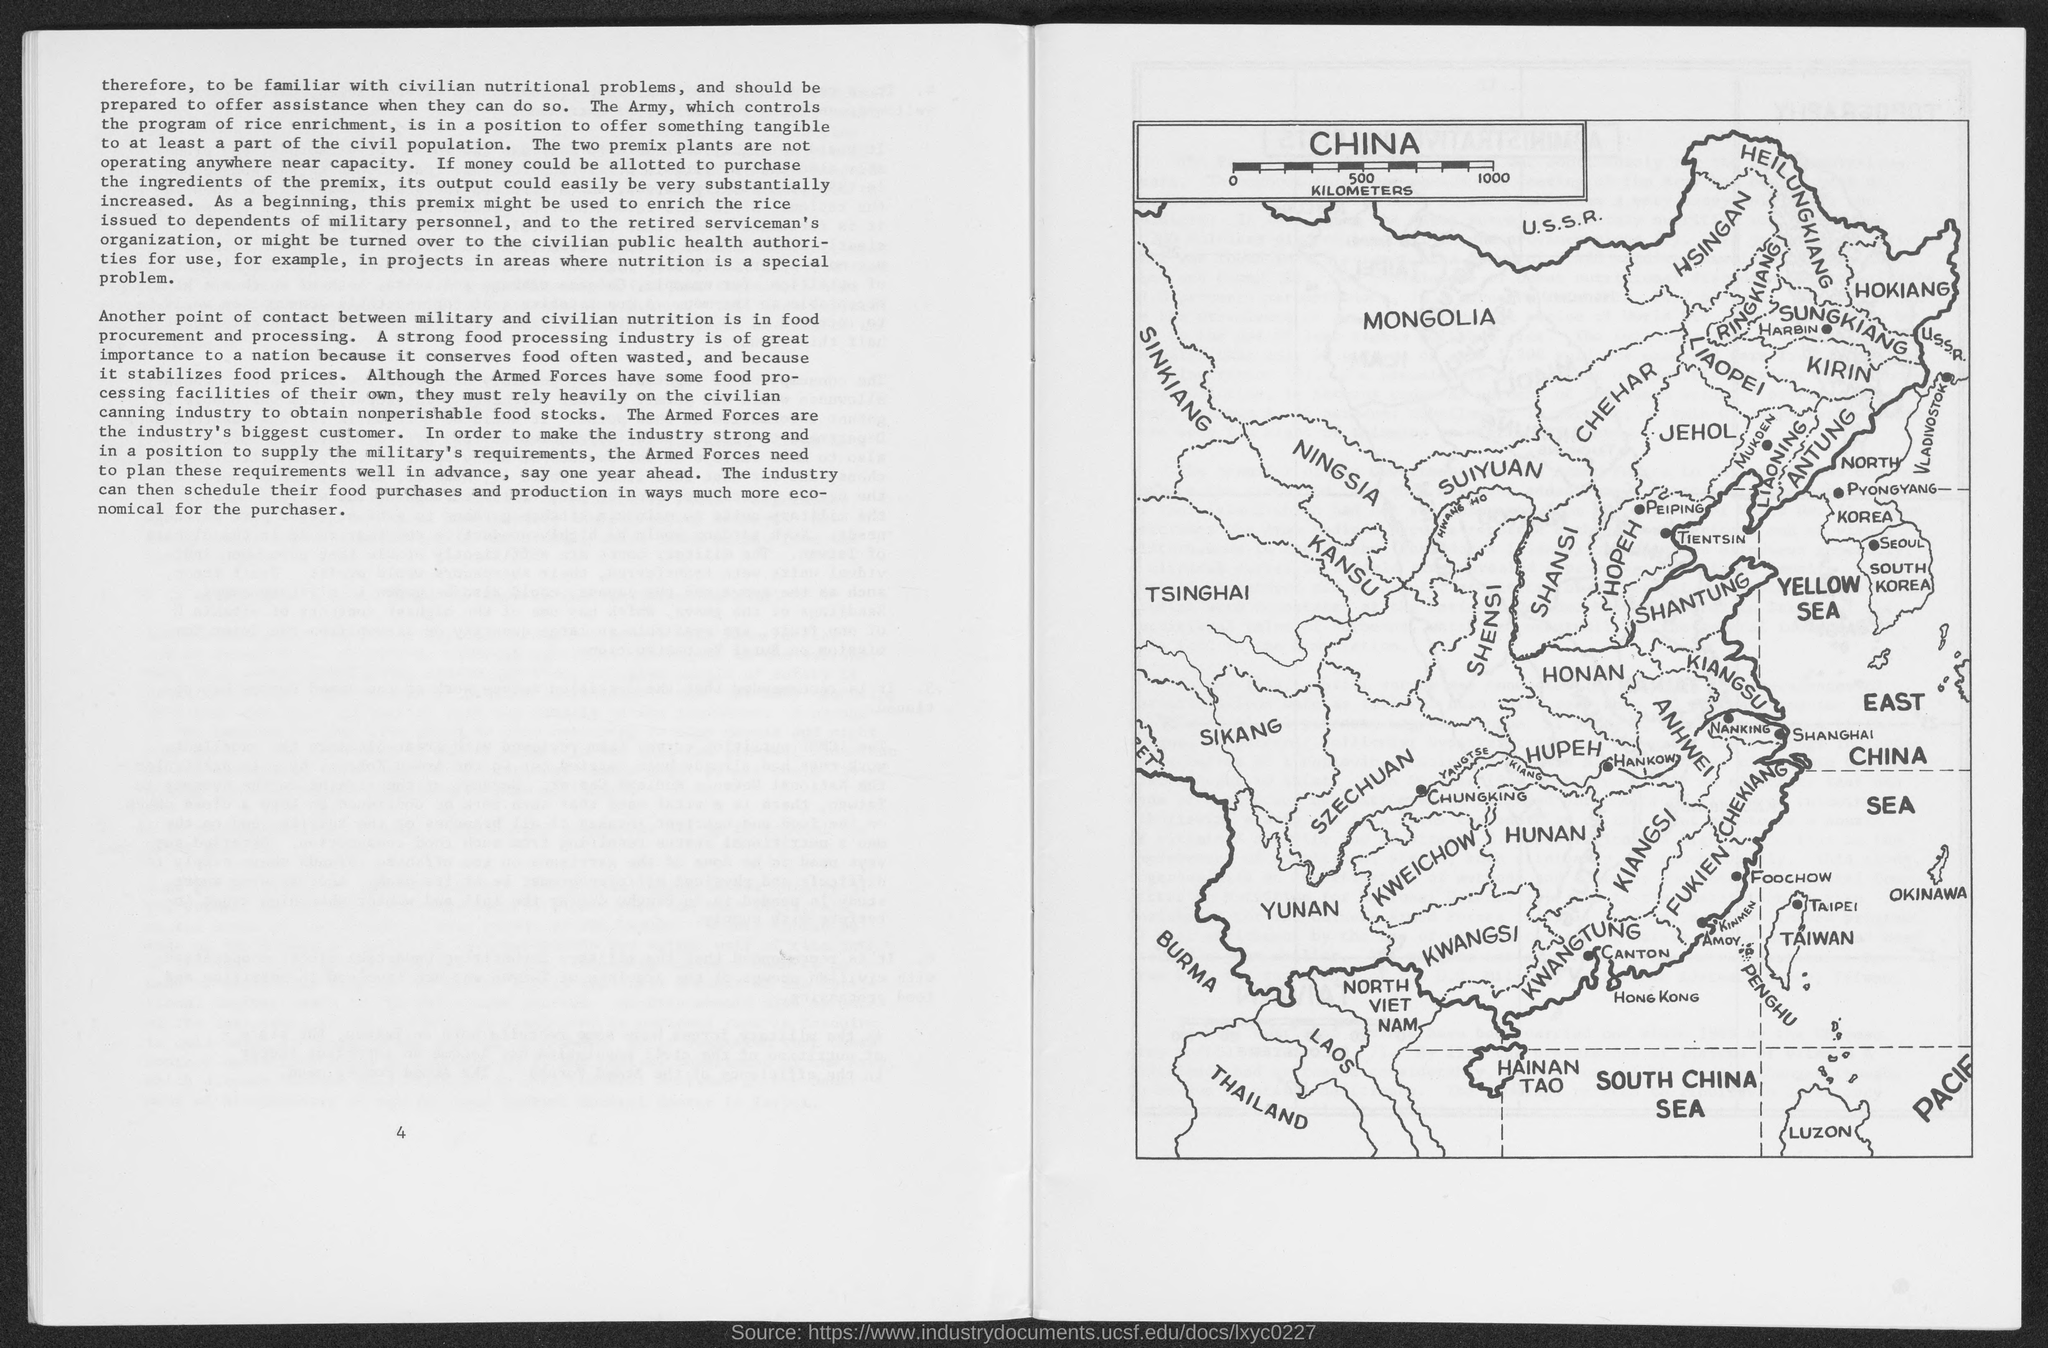Outline some significant characteristics in this image. The armed forces are the biggest customers in the industry. The text that is written in bold and larger font directly below the word 'TAIPEI' on a map is 'TAIWAN'. The text "China" is written in the largest font size and is located in the top left corner rectangle box on the map. On the map in the right bottom corner, the text "SOUTH CHINA SEA" is written in smaller size font letters, and between them, the text "PACIF" is written in smaller size font letters. In the same corner, the text "LUZON" is written in smaller size font letters, and it is located in the Philippines. The word 'SUIYAUAN' in the map is written in capital letters just left of the word 'NINGSIA', and the letter 'N' is capitalized. The written letter 'N' is replaced with 'NINGSIA'. 